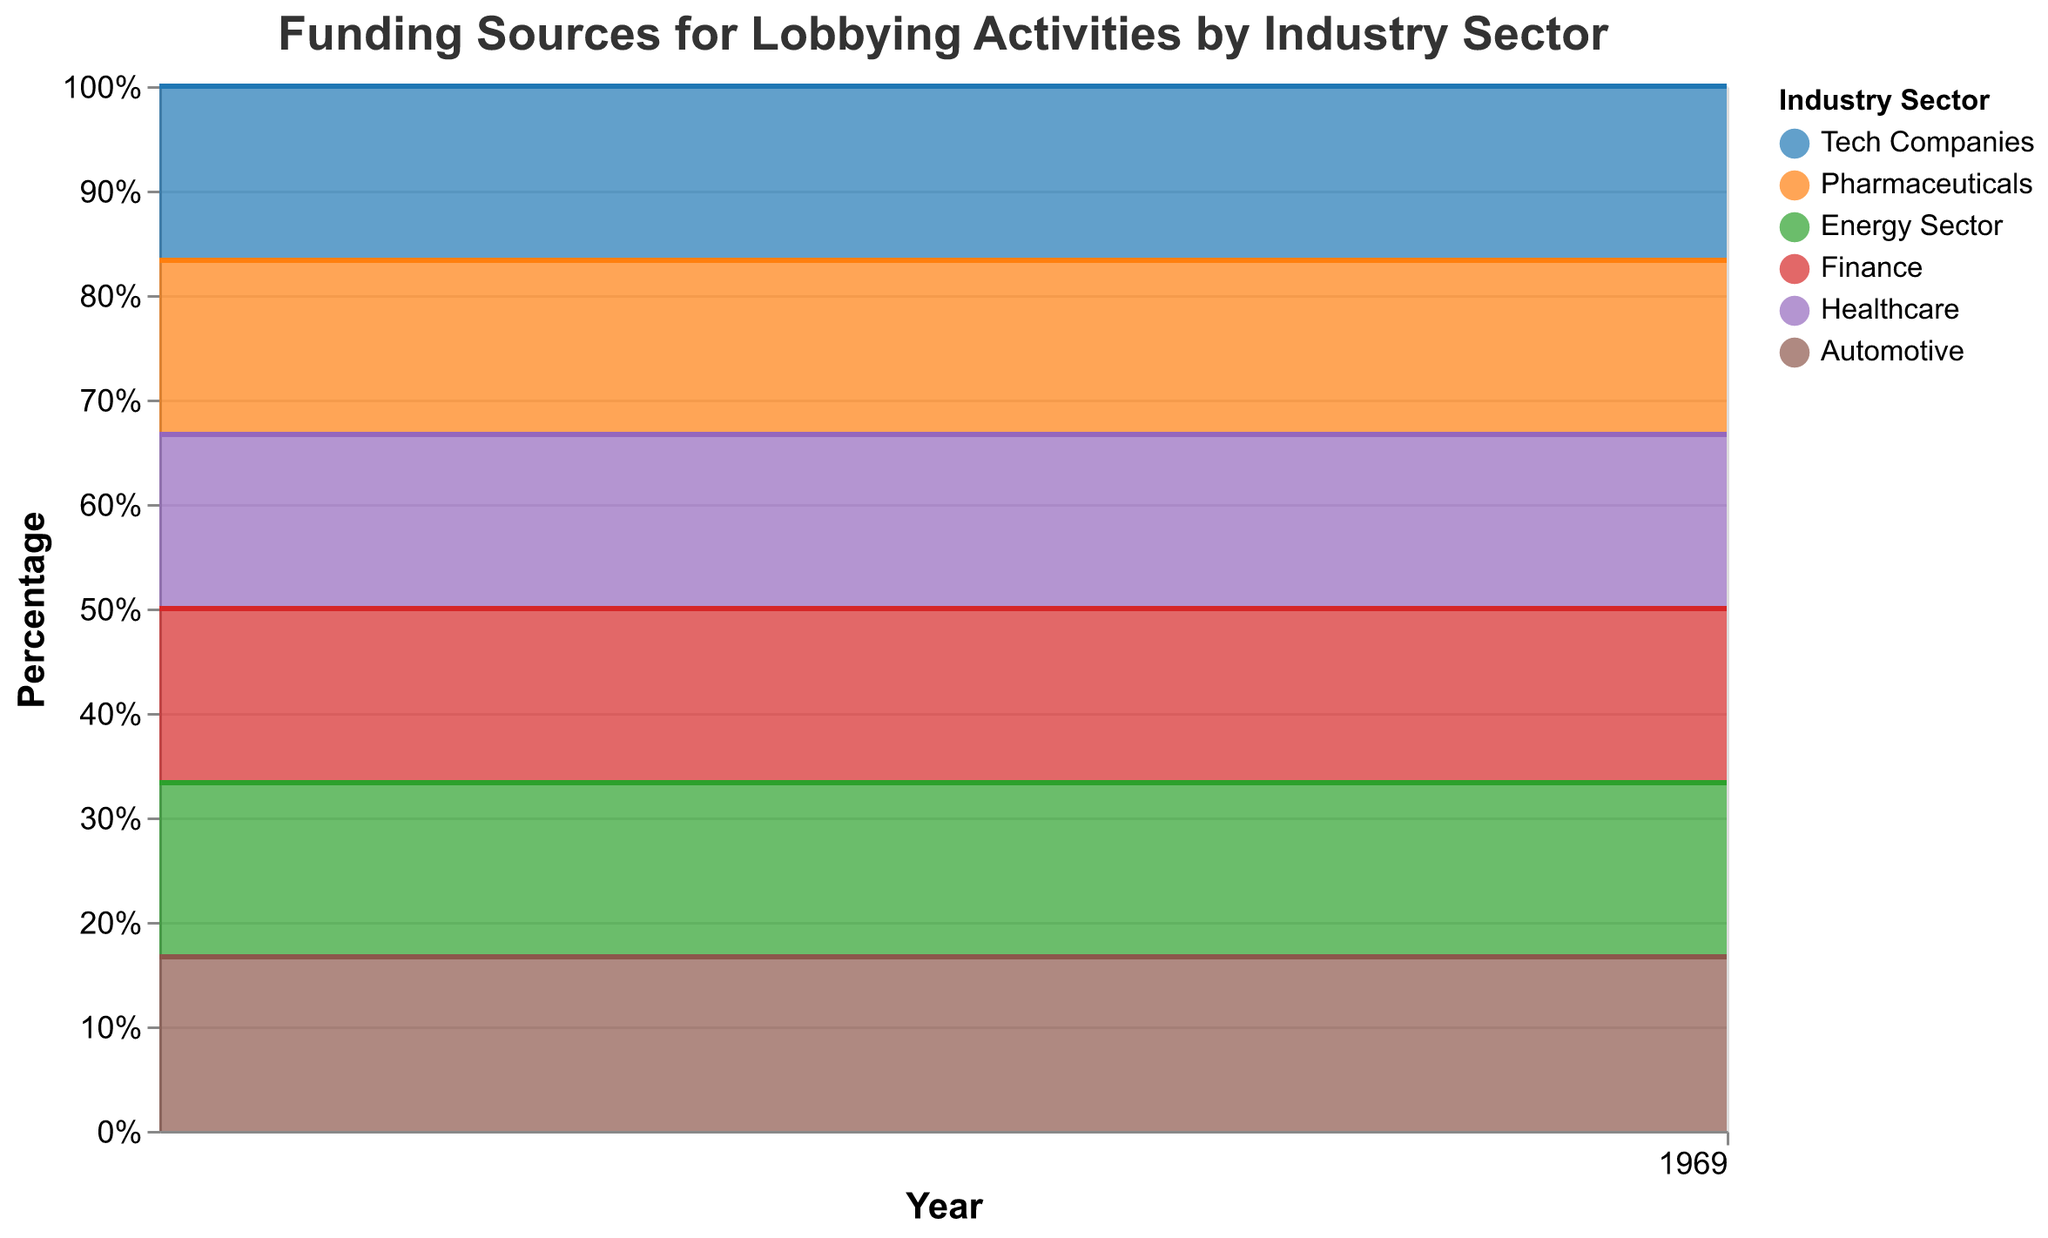What is the title of the chart? The title is displayed at the top of the chart, indicating the subject of the figure.
Answer: Funding Sources for Lobbying Activities by Industry Sector Which sector had the highest percentage of lobbying funding in 2022? Look at the width of each color band on the rightmost side of the chart for the year 2022. The widest band is for Tech Companies.
Answer: Tech Companies How did the percentage of lobbying funding from the Pharmaceutical sector change from 2018 to 2022? Observe the orange band's thickness from 2018 to 2022. The thickness decreases from 30% to 18%.
Answer: Decreased Which two sectors swapped funding dominance between 2018 and 2022? Compare each year and notice any intersections. The Tech Companies (blue) overtook Pharmaceuticals (orange) in dominance.
Answer: Tech Companies and Pharmaceuticals What trend can be observed for the Energy Sector from 2018 to 2022? Observe the green band's thickness from 2018 to 2022. It consistently increased from 10% to 20%.
Answer: Increasing In 2019, what was the combined percentage of lobbying funding for Finance and Healthcare sectors? Identify the height of the red and purple bands for 2019 and sum their values (18% + 12%).
Answer: 30% Did the Automotive sector's percentage of lobbying funding change from 2018 to 2022? Observe the brown band's thickness across all years; it remains 5%.
Answer: No Which sector saw the most significant increase in the percentage of lobbying funding between 2018 and 2022? Assess each sector's thickness; Tech Companies grew significantly from 20% to 40%.
Answer: Tech Companies Which year saw the highest percentage of lobbying funding from Tech Companies? Find the year where the blue band is the thickest. It's thickest in 2022.
Answer: 2022 